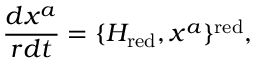<formula> <loc_0><loc_0><loc_500><loc_500>\frac { d x ^ { a } } { r d t } = \{ H _ { r e d } , x ^ { a } \} ^ { r e d } ,</formula> 